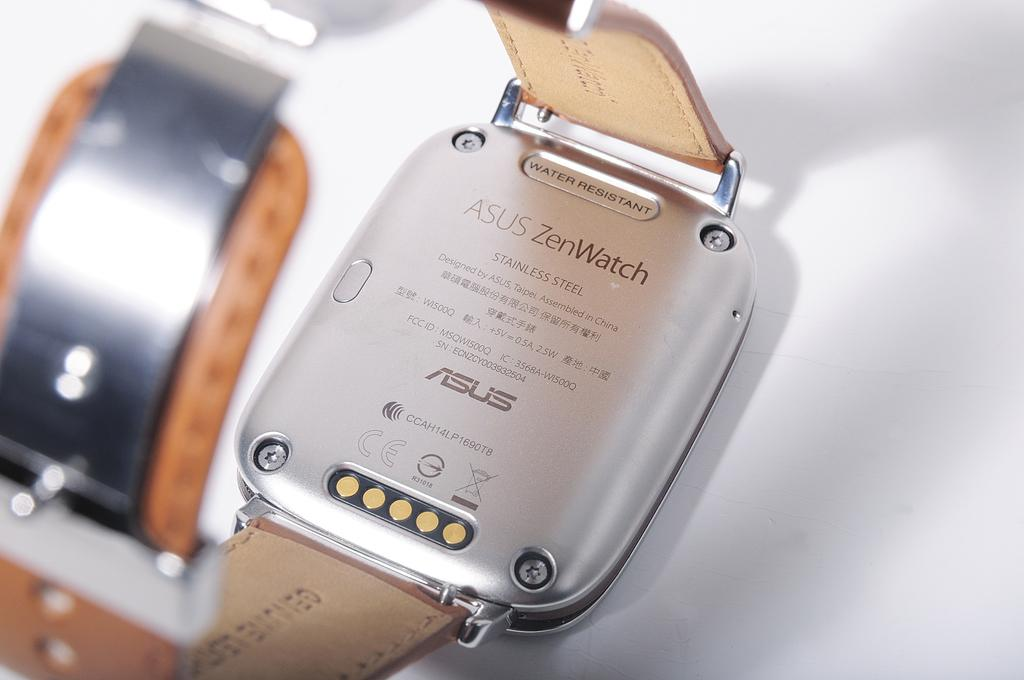Provide a one-sentence caption for the provided image. a watch and the brand is asus watch. 